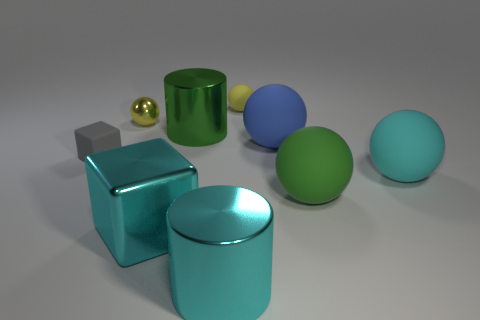What number of large spheres are left of the yellow matte thing that is on the right side of the block that is in front of the large cyan ball? 0 